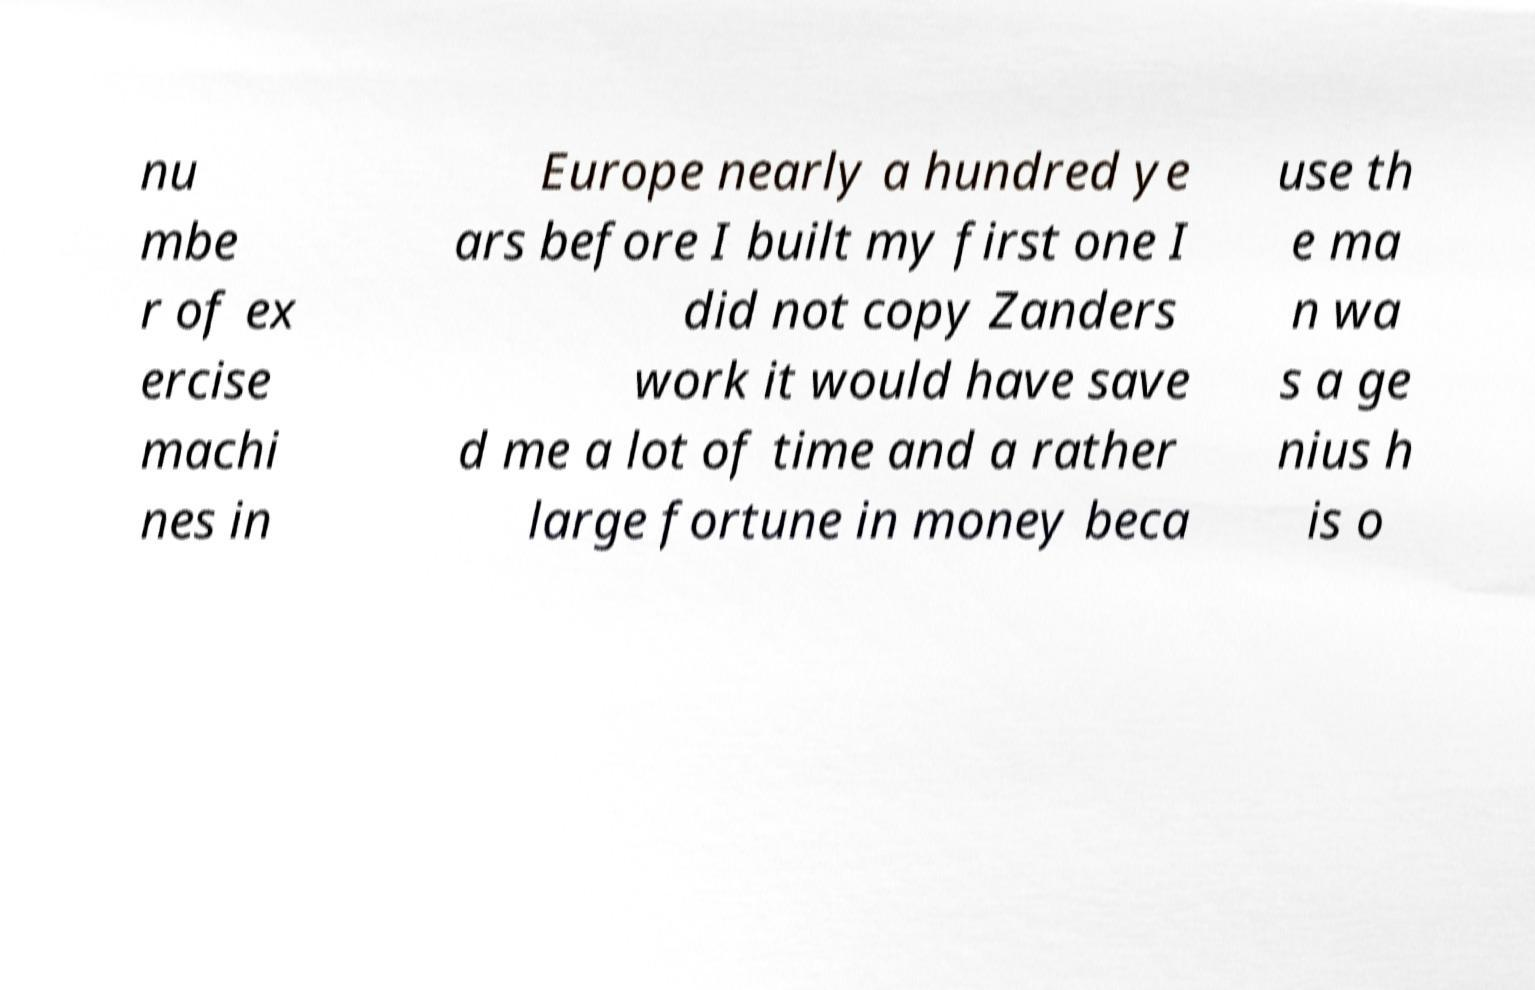There's text embedded in this image that I need extracted. Can you transcribe it verbatim? nu mbe r of ex ercise machi nes in Europe nearly a hundred ye ars before I built my first one I did not copy Zanders work it would have save d me a lot of time and a rather large fortune in money beca use th e ma n wa s a ge nius h is o 